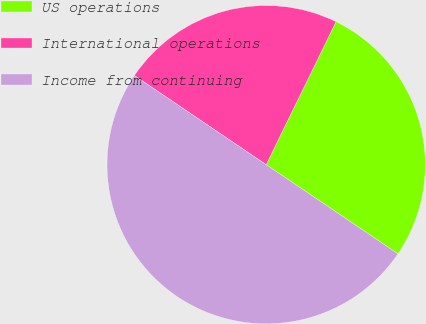Convert chart to OTSL. <chart><loc_0><loc_0><loc_500><loc_500><pie_chart><fcel>US operations<fcel>International operations<fcel>Income from continuing<nl><fcel>27.23%<fcel>22.77%<fcel>50.0%<nl></chart> 